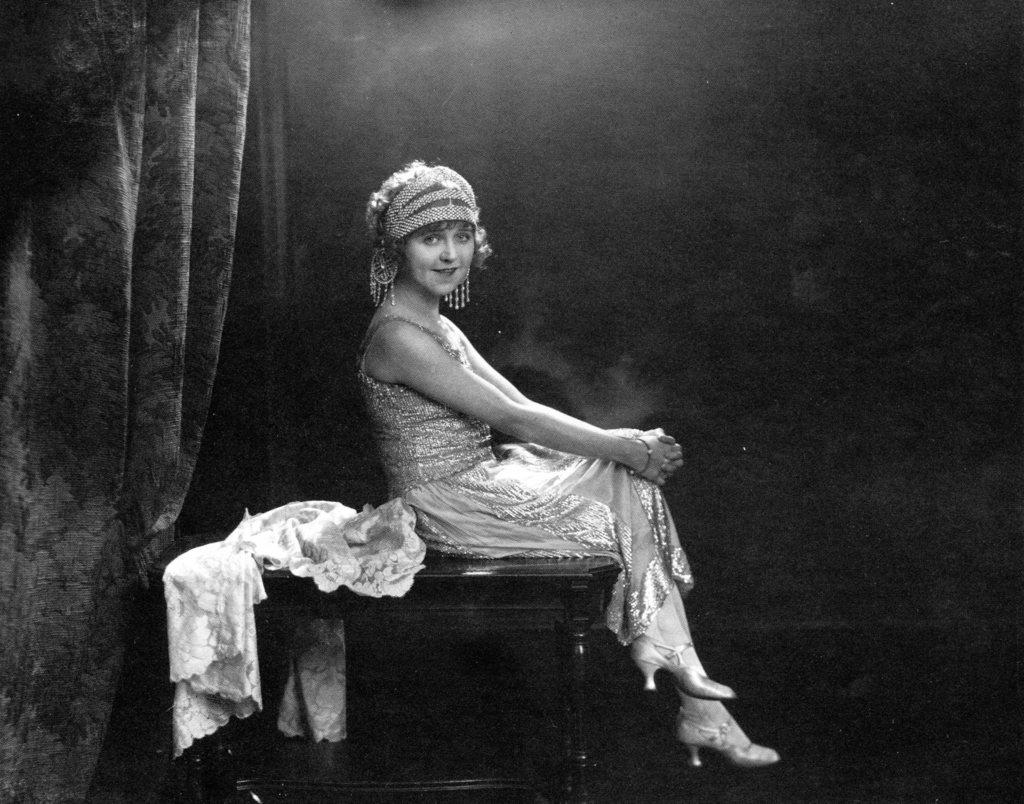What is the color scheme of the image? The image is black and white. Who is the main subject in the image? There is a girl in the image. What is the girl doing in the image? The girl is sitting on a table. What is the girl wearing in the image? The girl is wearing a costume. What can be seen on the left side of the image? There is a curtain on the left side of the image. What type of accessory is the girl wearing? The girl has long earrings. Can you tell me how many kitties are sitting on the table with the girl? There are no kitties present in the image; it only features the girl sitting on the table. What type of calculator is the girl using in the image? There is no calculator present in the image; the girl is wearing a costume and sitting on a table. 